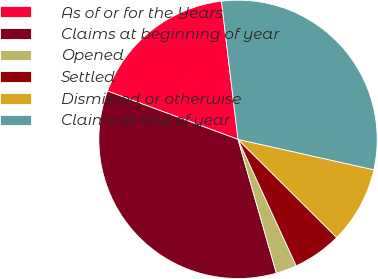Convert chart. <chart><loc_0><loc_0><loc_500><loc_500><pie_chart><fcel>As of or for the Years<fcel>Claims at beginning of year<fcel>Opened<fcel>Settled<fcel>Dismissed or otherwise<fcel>Claims at end of year<nl><fcel>17.46%<fcel>35.08%<fcel>2.42%<fcel>5.68%<fcel>8.95%<fcel>30.4%<nl></chart> 